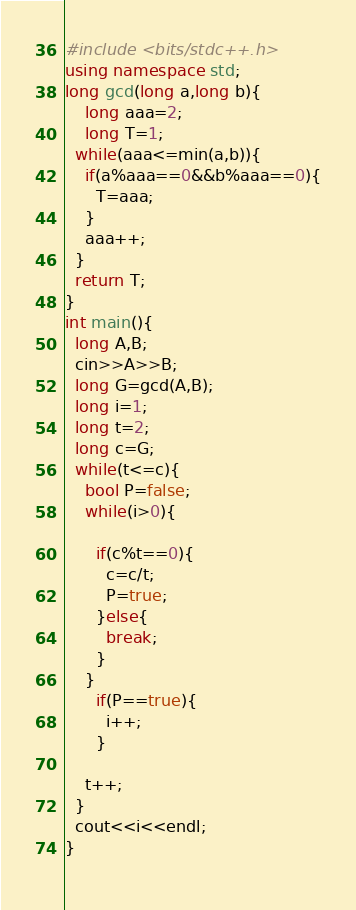<code> <loc_0><loc_0><loc_500><loc_500><_C++_>#include <bits/stdc++.h>
using namespace std;
long gcd(long a,long b){
	long aaa=2;
    long T=1;
  while(aaa<=min(a,b)){
	if(a%aaa==0&&b%aaa==0){
      T=aaa;
    }
    aaa++;
  }
  return T;
}
int main(){
  long A,B;
  cin>>A>>B;
  long G=gcd(A,B);
  long i=1;
  long t=2;
  long c=G;
  while(t<=c){
    bool P=false;
    while(i>0){
      
      if(c%t==0){
        c=c/t;
        P=true;
      }else{
        break;
      }
    }
      if(P==true){
        i++;
      }
    
    t++;
  }
  cout<<i<<endl;
}
  </code> 